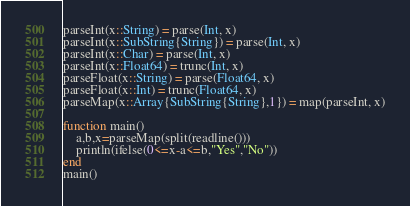Convert code to text. <code><loc_0><loc_0><loc_500><loc_500><_Julia_>parseInt(x::String) = parse(Int, x)
parseInt(x::SubString{String}) = parse(Int, x)
parseInt(x::Char) = parse(Int, x)
parseInt(x::Float64) = trunc(Int, x)
parseFloat(x::String) = parse(Float64, x)
parseFloat(x::Int) = trunc(Float64, x)
parseMap(x::Array{SubString{String},1}) = map(parseInt, x)

function main()
    a,b,x=parseMap(split(readline()))
    println(ifelse(0<=x-a<=b,"Yes","No"))
end
main()</code> 